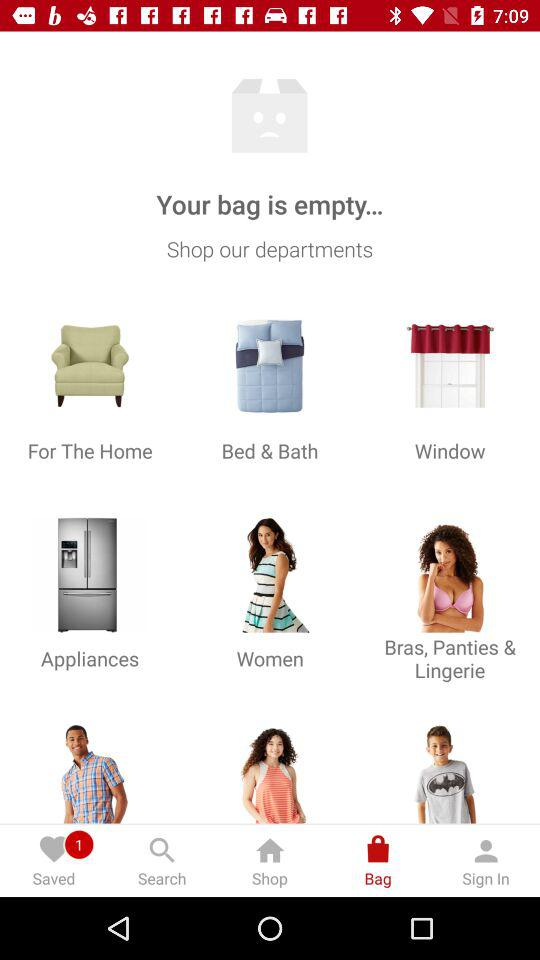What is the count of saved items? The count of saved items is 1. 